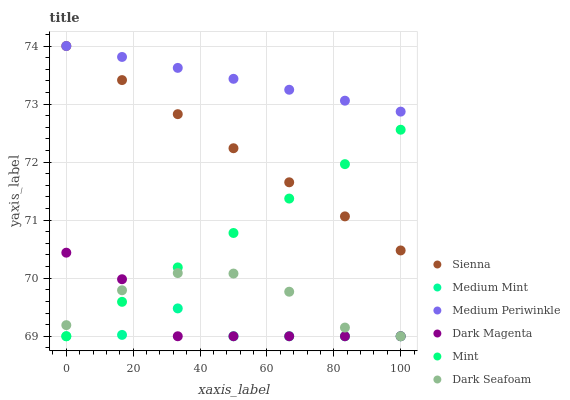Does Medium Mint have the minimum area under the curve?
Answer yes or no. Yes. Does Medium Periwinkle have the maximum area under the curve?
Answer yes or no. Yes. Does Dark Magenta have the minimum area under the curve?
Answer yes or no. No. Does Dark Magenta have the maximum area under the curve?
Answer yes or no. No. Is Mint the smoothest?
Answer yes or no. Yes. Is Medium Mint the roughest?
Answer yes or no. Yes. Is Dark Magenta the smoothest?
Answer yes or no. No. Is Dark Magenta the roughest?
Answer yes or no. No. Does Medium Mint have the lowest value?
Answer yes or no. Yes. Does Medium Periwinkle have the lowest value?
Answer yes or no. No. Does Sienna have the highest value?
Answer yes or no. Yes. Does Dark Magenta have the highest value?
Answer yes or no. No. Is Dark Magenta less than Medium Periwinkle?
Answer yes or no. Yes. Is Medium Periwinkle greater than Dark Magenta?
Answer yes or no. Yes. Does Dark Magenta intersect Medium Mint?
Answer yes or no. Yes. Is Dark Magenta less than Medium Mint?
Answer yes or no. No. Is Dark Magenta greater than Medium Mint?
Answer yes or no. No. Does Dark Magenta intersect Medium Periwinkle?
Answer yes or no. No. 